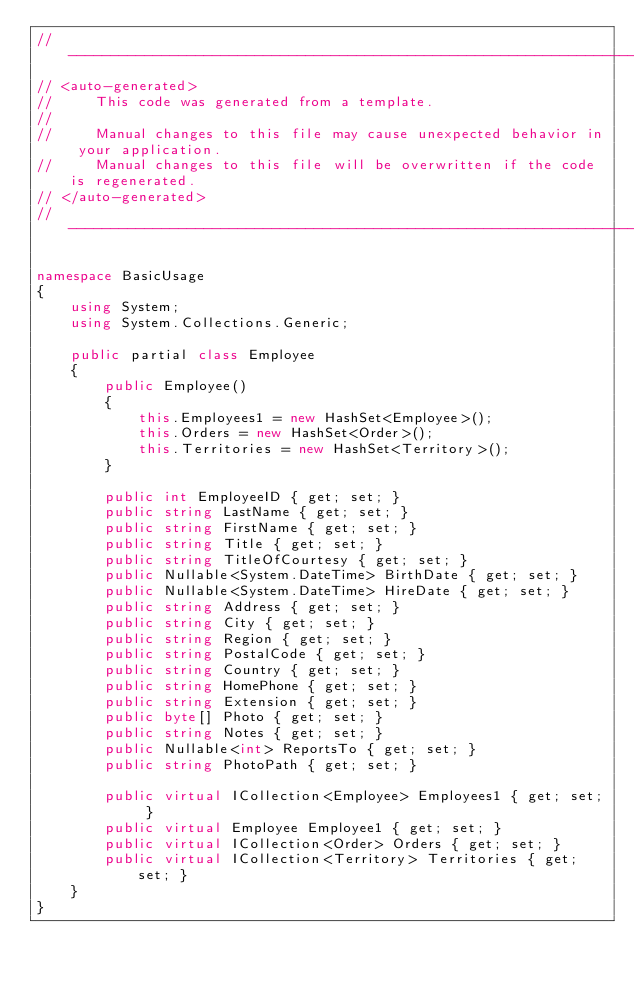<code> <loc_0><loc_0><loc_500><loc_500><_C#_>//------------------------------------------------------------------------------
// <auto-generated>
//     This code was generated from a template.
//
//     Manual changes to this file may cause unexpected behavior in your application.
//     Manual changes to this file will be overwritten if the code is regenerated.
// </auto-generated>
//------------------------------------------------------------------------------

namespace BasicUsage
{
    using System;
    using System.Collections.Generic;
    
    public partial class Employee
    {
        public Employee()
        {
            this.Employees1 = new HashSet<Employee>();
            this.Orders = new HashSet<Order>();
            this.Territories = new HashSet<Territory>();
        }
    
        public int EmployeeID { get; set; }
        public string LastName { get; set; }
        public string FirstName { get; set; }
        public string Title { get; set; }
        public string TitleOfCourtesy { get; set; }
        public Nullable<System.DateTime> BirthDate { get; set; }
        public Nullable<System.DateTime> HireDate { get; set; }
        public string Address { get; set; }
        public string City { get; set; }
        public string Region { get; set; }
        public string PostalCode { get; set; }
        public string Country { get; set; }
        public string HomePhone { get; set; }
        public string Extension { get; set; }
        public byte[] Photo { get; set; }
        public string Notes { get; set; }
        public Nullable<int> ReportsTo { get; set; }
        public string PhotoPath { get; set; }
    
        public virtual ICollection<Employee> Employees1 { get; set; }
        public virtual Employee Employee1 { get; set; }
        public virtual ICollection<Order> Orders { get; set; }
        public virtual ICollection<Territory> Territories { get; set; }
    }
}
</code> 